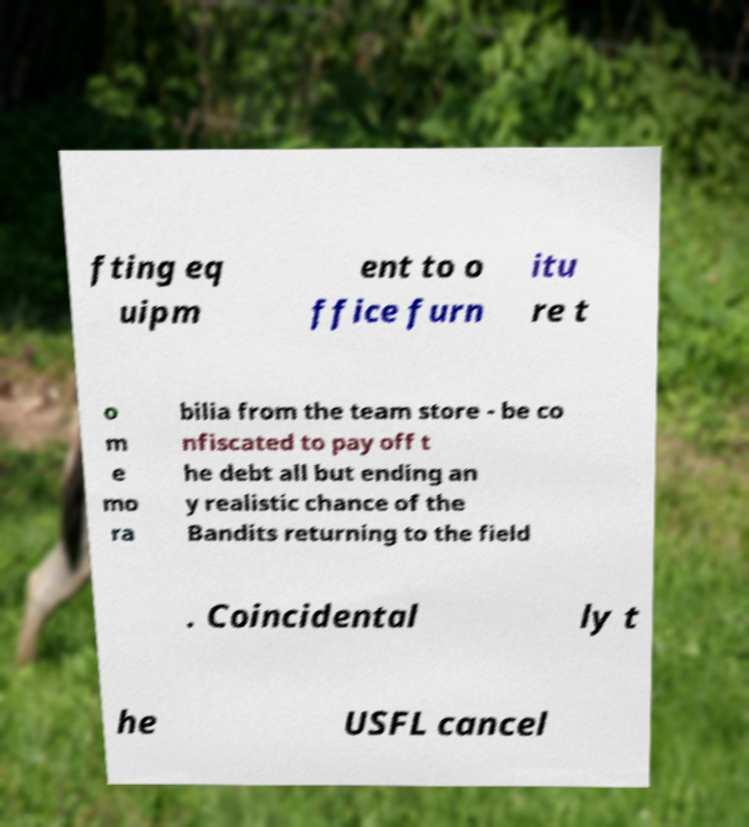Could you extract and type out the text from this image? fting eq uipm ent to o ffice furn itu re t o m e mo ra bilia from the team store - be co nfiscated to pay off t he debt all but ending an y realistic chance of the Bandits returning to the field . Coincidental ly t he USFL cancel 